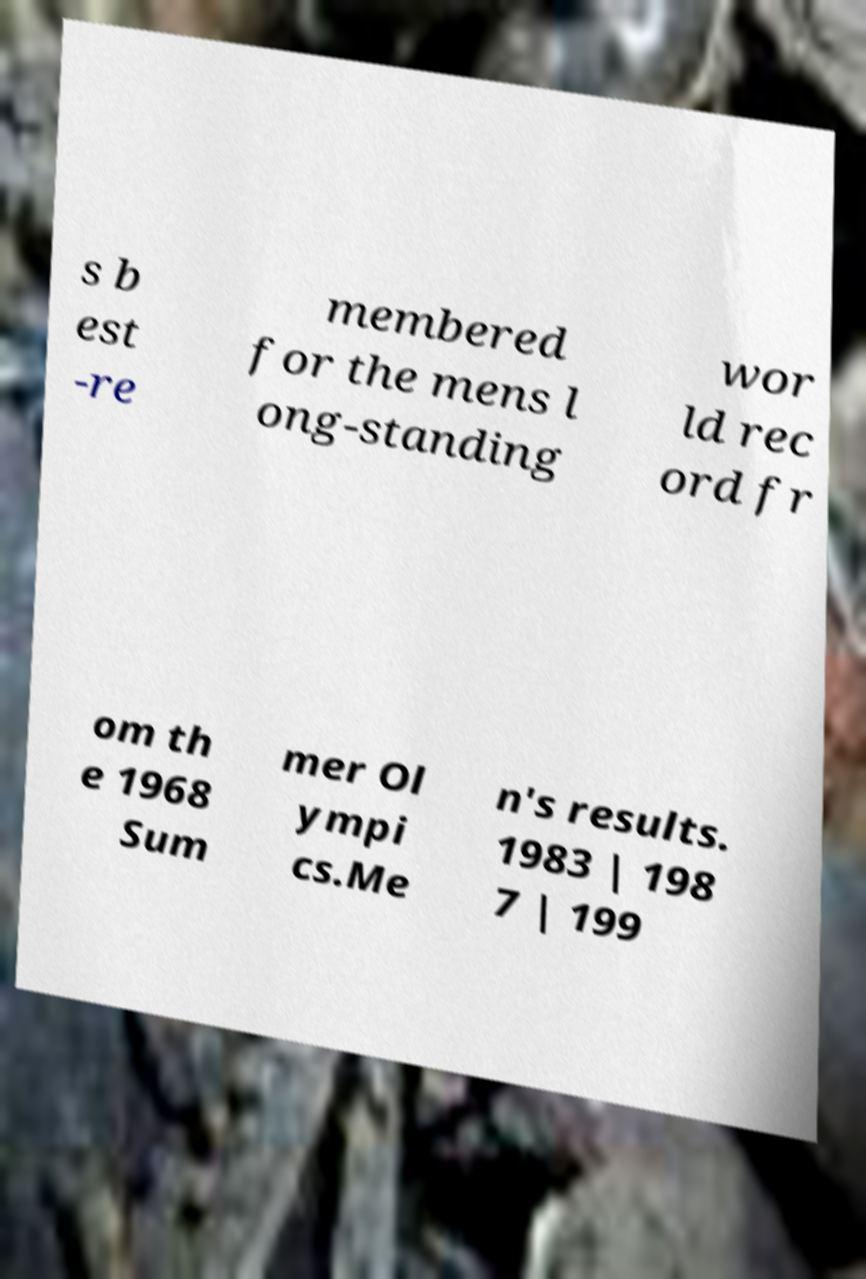Can you accurately transcribe the text from the provided image for me? s b est -re membered for the mens l ong-standing wor ld rec ord fr om th e 1968 Sum mer Ol ympi cs.Me n's results. 1983 | 198 7 | 199 